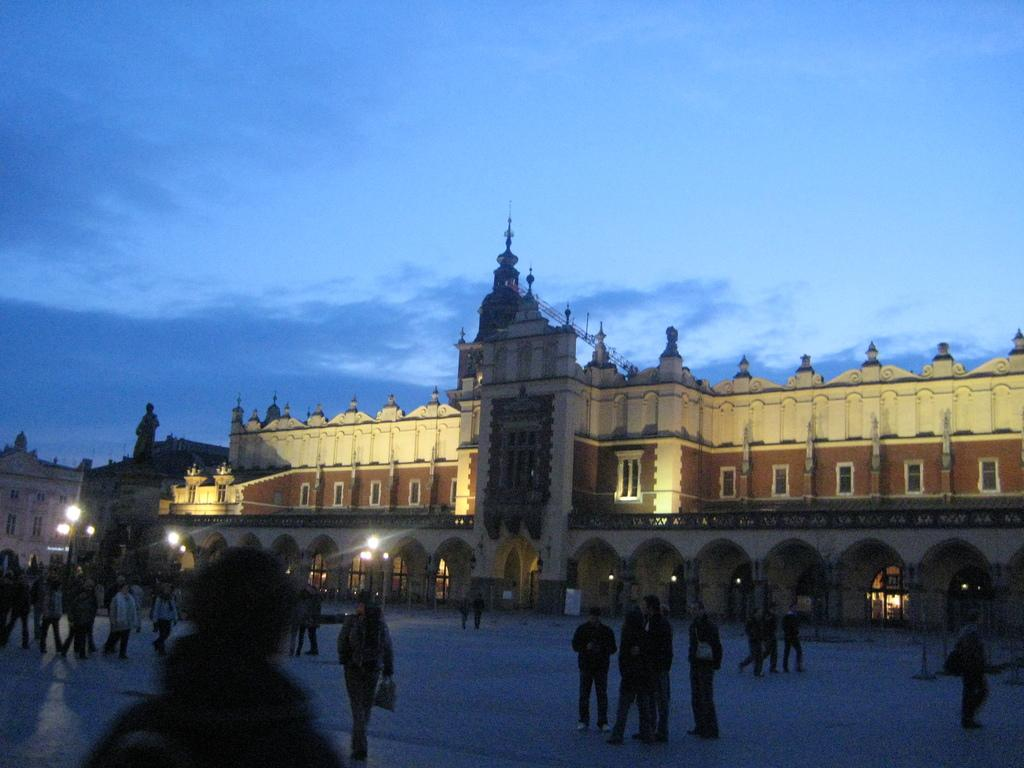What type of building is in the image? There is a palace in the image. What is in front of the palace? There is a pavement in front of the palace. What can be seen on the pavement? There are many people on the pavement. What type of operation is being performed on the palace in the image? There is no operation being performed on the palace in the image. What is the cork used for in the image? There is no cork present in the image. 